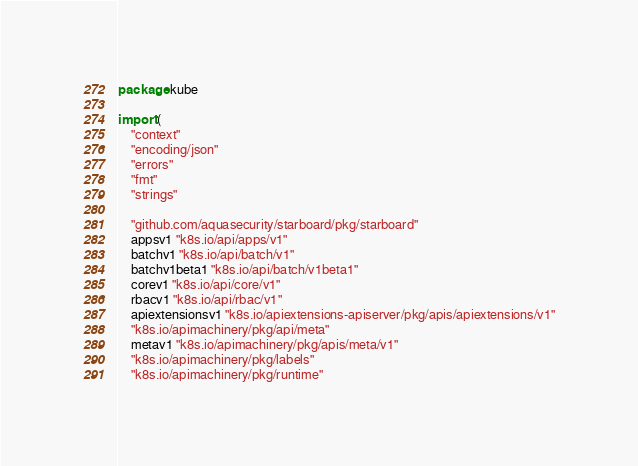<code> <loc_0><loc_0><loc_500><loc_500><_Go_>package kube

import (
	"context"
	"encoding/json"
	"errors"
	"fmt"
	"strings"

	"github.com/aquasecurity/starboard/pkg/starboard"
	appsv1 "k8s.io/api/apps/v1"
	batchv1 "k8s.io/api/batch/v1"
	batchv1beta1 "k8s.io/api/batch/v1beta1"
	corev1 "k8s.io/api/core/v1"
	rbacv1 "k8s.io/api/rbac/v1"
	apiextensionsv1 "k8s.io/apiextensions-apiserver/pkg/apis/apiextensions/v1"
	"k8s.io/apimachinery/pkg/api/meta"
	metav1 "k8s.io/apimachinery/pkg/apis/meta/v1"
	"k8s.io/apimachinery/pkg/labels"
	"k8s.io/apimachinery/pkg/runtime"</code> 